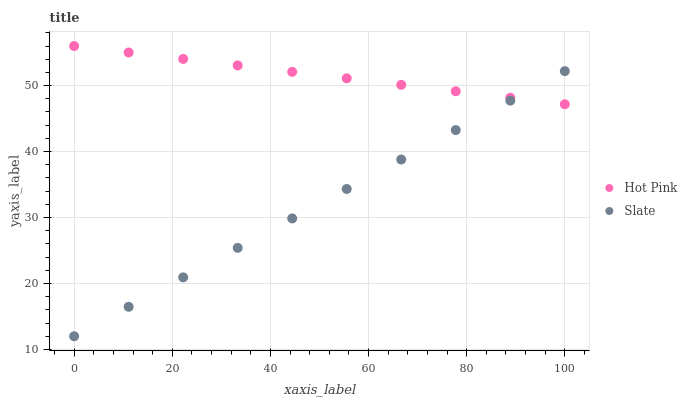Does Slate have the minimum area under the curve?
Answer yes or no. Yes. Does Hot Pink have the maximum area under the curve?
Answer yes or no. Yes. Does Hot Pink have the minimum area under the curve?
Answer yes or no. No. Is Slate the smoothest?
Answer yes or no. Yes. Is Hot Pink the roughest?
Answer yes or no. Yes. Is Hot Pink the smoothest?
Answer yes or no. No. Does Slate have the lowest value?
Answer yes or no. Yes. Does Hot Pink have the lowest value?
Answer yes or no. No. Does Hot Pink have the highest value?
Answer yes or no. Yes. Does Slate intersect Hot Pink?
Answer yes or no. Yes. Is Slate less than Hot Pink?
Answer yes or no. No. Is Slate greater than Hot Pink?
Answer yes or no. No. 